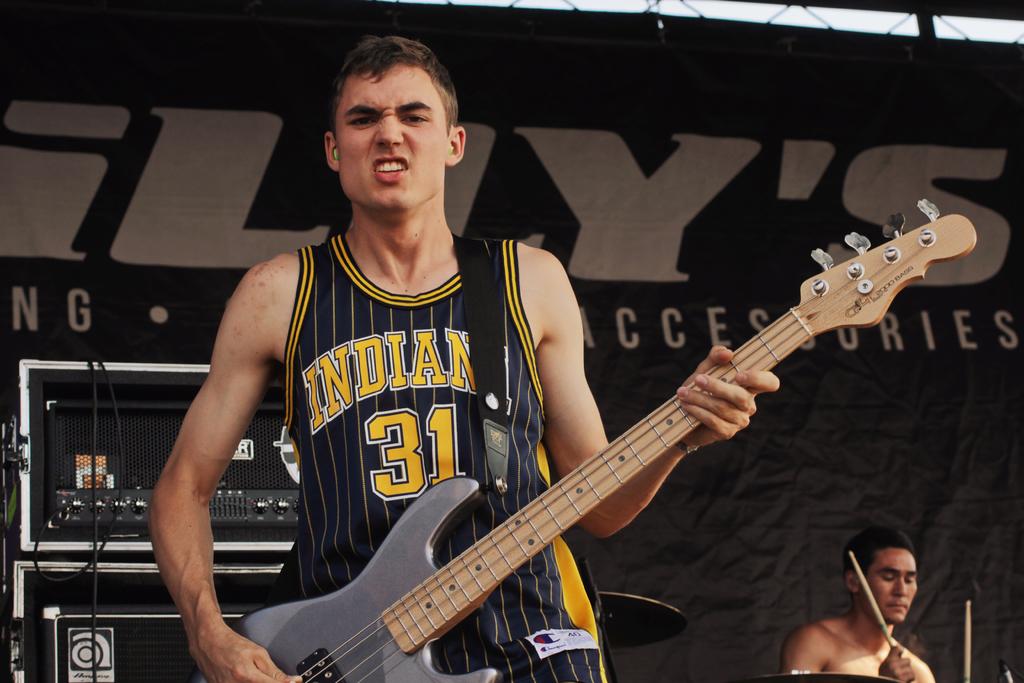What number is on the jersey?
Give a very brief answer. 31. 